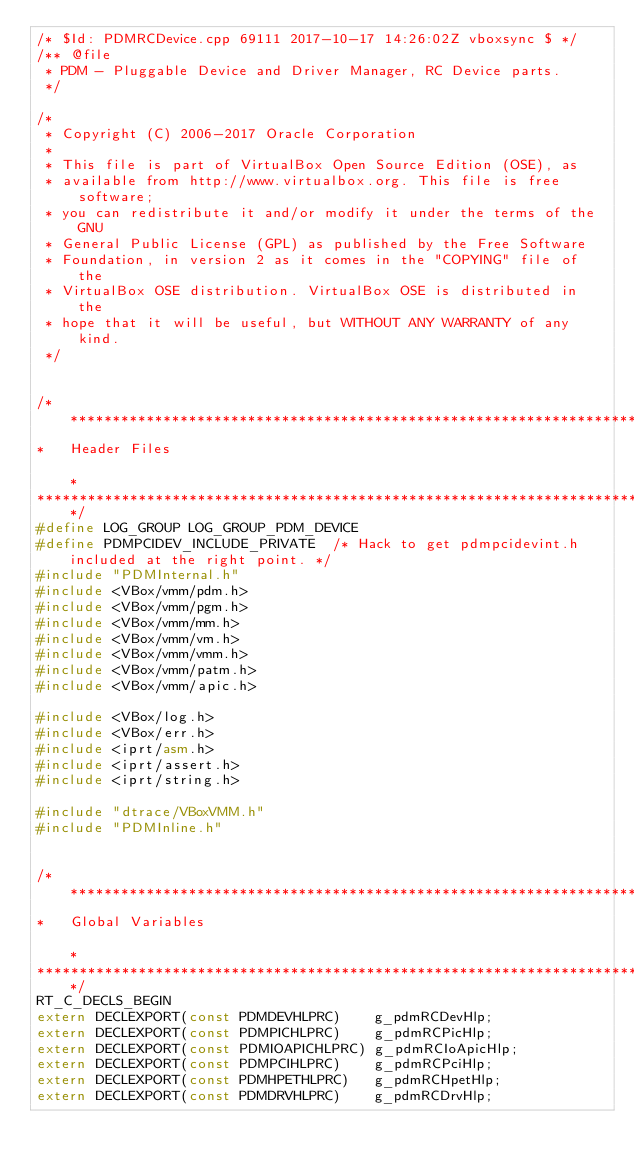Convert code to text. <code><loc_0><loc_0><loc_500><loc_500><_C++_>/* $Id: PDMRCDevice.cpp 69111 2017-10-17 14:26:02Z vboxsync $ */
/** @file
 * PDM - Pluggable Device and Driver Manager, RC Device parts.
 */

/*
 * Copyright (C) 2006-2017 Oracle Corporation
 *
 * This file is part of VirtualBox Open Source Edition (OSE), as
 * available from http://www.virtualbox.org. This file is free software;
 * you can redistribute it and/or modify it under the terms of the GNU
 * General Public License (GPL) as published by the Free Software
 * Foundation, in version 2 as it comes in the "COPYING" file of the
 * VirtualBox OSE distribution. VirtualBox OSE is distributed in the
 * hope that it will be useful, but WITHOUT ANY WARRANTY of any kind.
 */


/*********************************************************************************************************************************
*   Header Files                                                                                                                 *
*********************************************************************************************************************************/
#define LOG_GROUP LOG_GROUP_PDM_DEVICE
#define PDMPCIDEV_INCLUDE_PRIVATE  /* Hack to get pdmpcidevint.h included at the right point. */
#include "PDMInternal.h"
#include <VBox/vmm/pdm.h>
#include <VBox/vmm/pgm.h>
#include <VBox/vmm/mm.h>
#include <VBox/vmm/vm.h>
#include <VBox/vmm/vmm.h>
#include <VBox/vmm/patm.h>
#include <VBox/vmm/apic.h>

#include <VBox/log.h>
#include <VBox/err.h>
#include <iprt/asm.h>
#include <iprt/assert.h>
#include <iprt/string.h>

#include "dtrace/VBoxVMM.h"
#include "PDMInline.h"


/*********************************************************************************************************************************
*   Global Variables                                                                                                             *
*********************************************************************************************************************************/
RT_C_DECLS_BEGIN
extern DECLEXPORT(const PDMDEVHLPRC)    g_pdmRCDevHlp;
extern DECLEXPORT(const PDMPICHLPRC)    g_pdmRCPicHlp;
extern DECLEXPORT(const PDMIOAPICHLPRC) g_pdmRCIoApicHlp;
extern DECLEXPORT(const PDMPCIHLPRC)    g_pdmRCPciHlp;
extern DECLEXPORT(const PDMHPETHLPRC)   g_pdmRCHpetHlp;
extern DECLEXPORT(const PDMDRVHLPRC)    g_pdmRCDrvHlp;</code> 